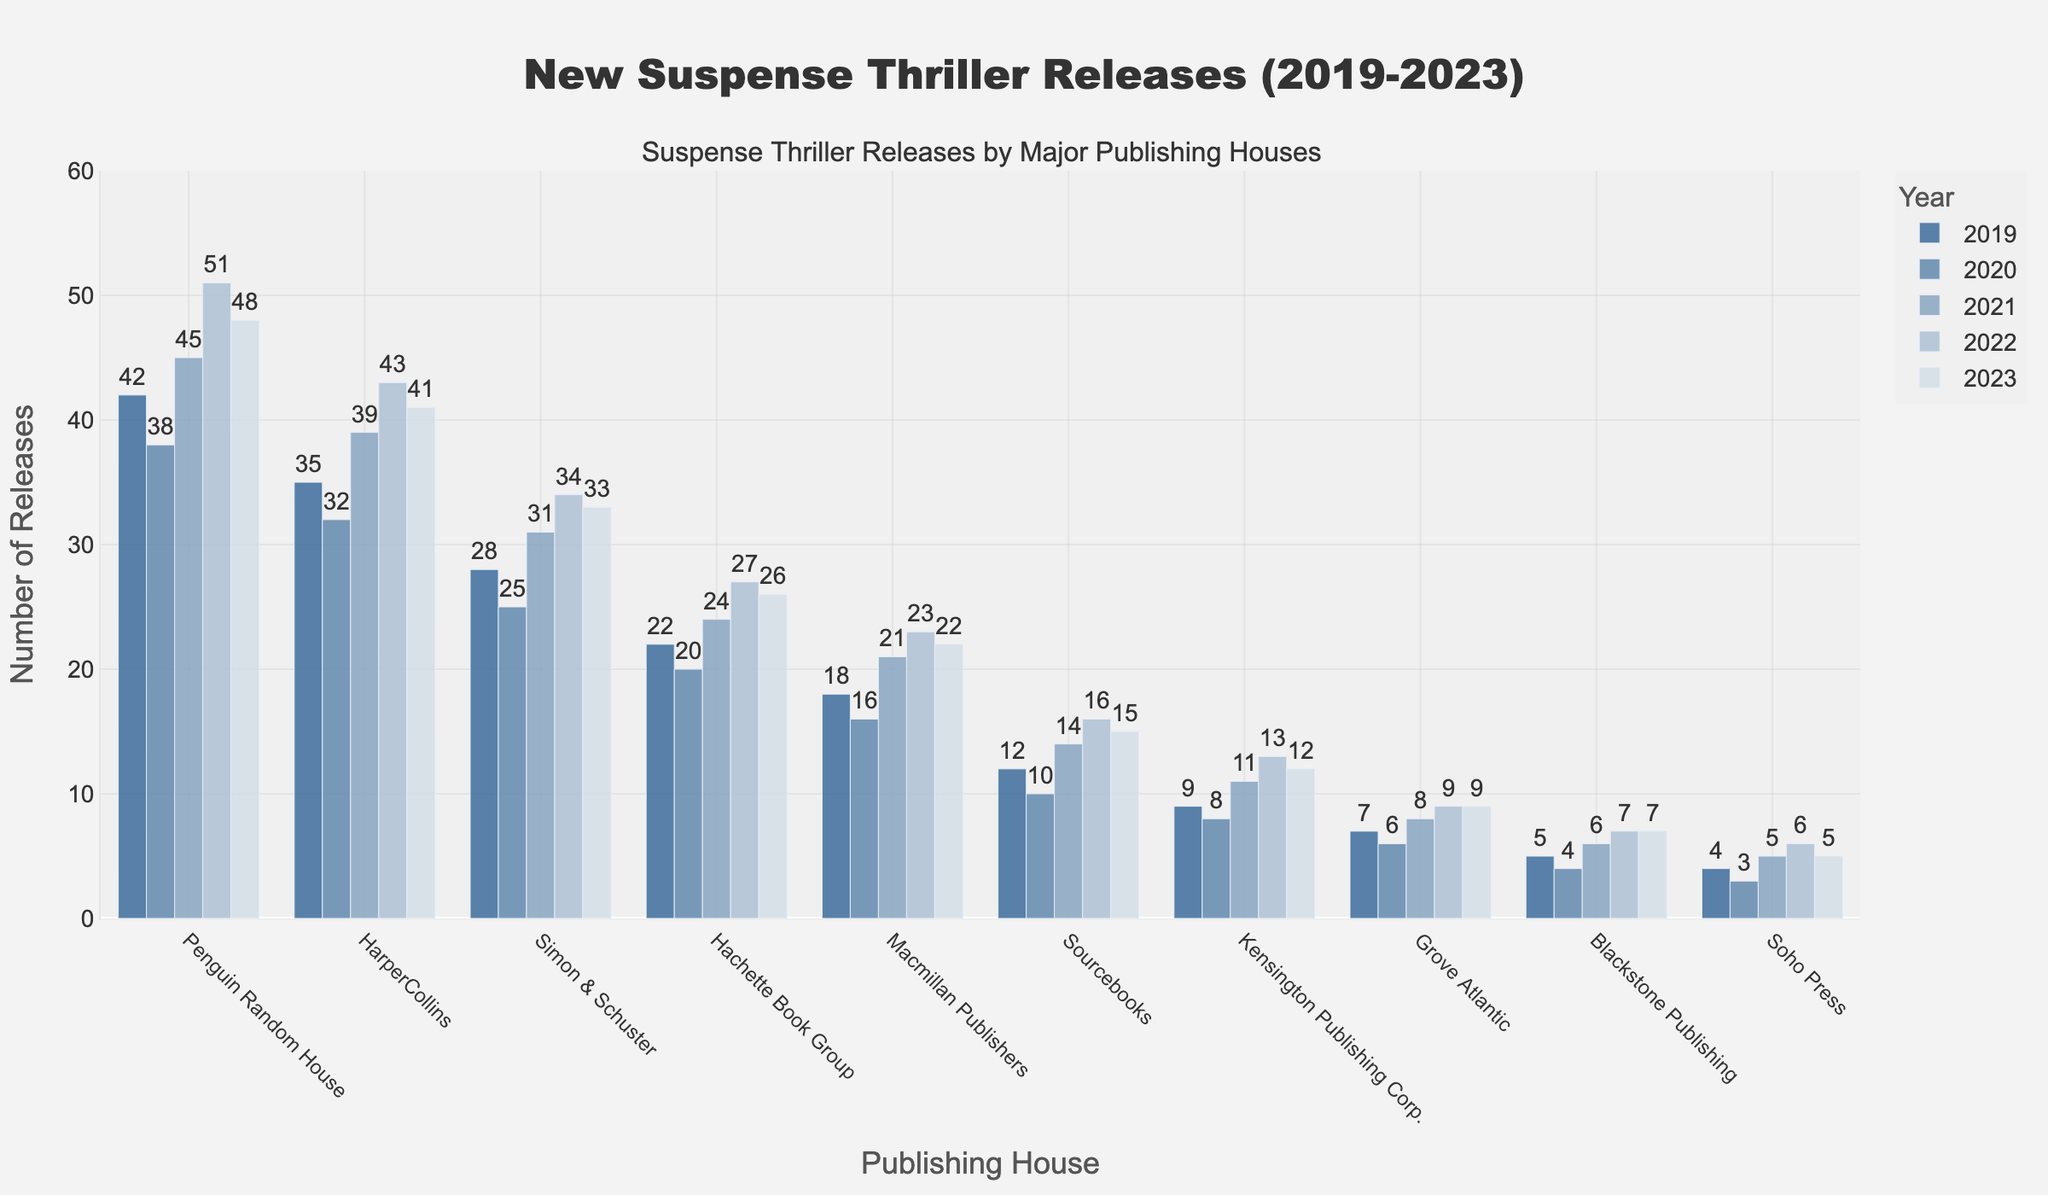How many more new releases did Penguin Random House have in 2023 compared to Sourcebooks? To find the difference, look at the number of releases for Penguin Random House in 2023 (48) and Sourcebooks in 2023 (15). Subtract the releases of Sourcebooks from Penguin Random House: 48 - 15.
Answer: 33 Which publishing house had the highest number of new releases in 2022? Look at the 2022 bars for each publishing house and identify the one with the highest value. In this case, Penguin Random House had 51 new releases.
Answer: Penguin Random House Calculate the average number of new releases for HarperCollins over the 5 years. Sum the values for HarperCollins from 2019 to 2023 (35 + 32 + 39 + 43 + 41 = 190). Then divide by the number of years (5): 190/5.
Answer: 38 Which publishing house had the smallest increase in new releases from 2020 to 2023? Calculate the difference between the 2023 and 2020 releases for each publishing house. The smallest increase is for Soho Press, from 3 to 5 (an increase of 2).
Answer: Soho Press What is the total number of new releases by Macmillan Publishers in the last 5 years? Sum the values for Macmillan Publishers from 2019 to 2023 (18 + 16 + 21 + 23 + 22).
Answer: 100 Which year had the highest total number of new releases for all publishing houses combined? Sum the releases for each year from 2019 to 2023, then compare:
2019: 42 + 35 + 28 + 22 + 18 + 12 + 9 + 7 + 5 + 4 = 182
2020: 38 + 32 + 25 + 20 + 16 + 10 + 8 + 6 + 4 + 3 = 162
2021: 45 + 39 + 31 + 24 + 21 + 14 + 11 + 8 + 6 + 5 = 204
2022: 51 + 43 + 34 + 27 + 23 + 16 + 13 + 9 + 7 + 6 = 229
2023: 48 + 41 + 33 + 26 + 22 + 15 + 12 + 9 + 7 + 5 = 218
The highest total is in 2022 with 229 releases.
Answer: 2022 Compare the change in new releases for HarperCollins and Simon & Schuster from 2019 to 2023. Which changed more? Calculate the difference for each: HarperCollins (41 - 35 = 6) and Simon & Schuster (33 - 28 = 5). HarperCollins has a change of 6, Simon & Schuster has a change of 5. HarperCollins had a greater change in new releases.
Answer: HarperCollins Identify the publishing house with the most consistent number of releases over the 5 years. Look for the publishing house with the least variation in its releases over the years. Blackstone Publishing had relatively consistent releases: 5, 4, 6, 7, 7. Check the standard deviations or variations for a more precise measure, Blackstone Publishing shows a small variation and hence appears most consistent.
Answer: Blackstone Publishing 